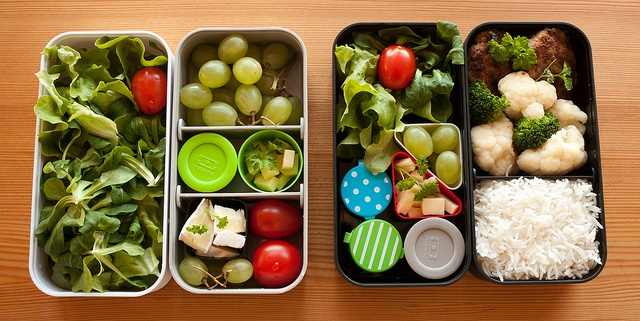Describe the objects in this image and their specific colors. I can see dining table in black, tan, olive, brown, and ivory tones, broccoli in tan, black, darkgreen, and olive tones, broccoli in tan, darkgreen, black, and olive tones, broccoli in tan, black, darkgreen, and olive tones, and broccoli in tan and beige tones in this image. 